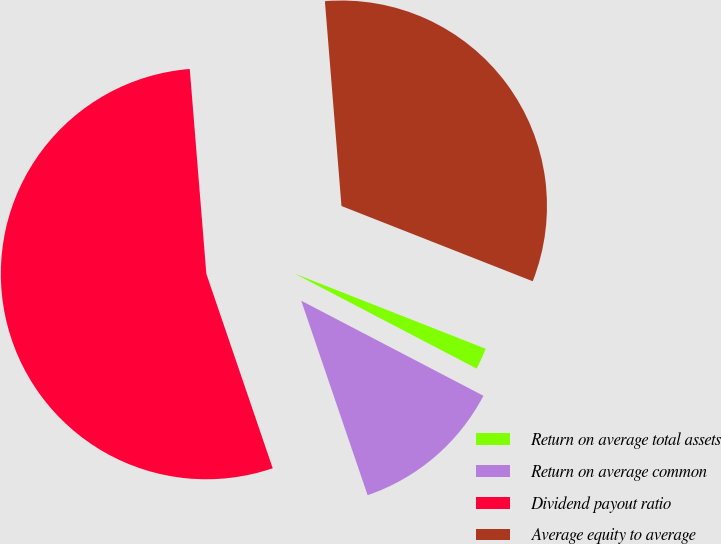Convert chart to OTSL. <chart><loc_0><loc_0><loc_500><loc_500><pie_chart><fcel>Return on average total assets<fcel>Return on average common<fcel>Dividend payout ratio<fcel>Average equity to average<nl><fcel>1.69%<fcel>12.11%<fcel>53.95%<fcel>32.25%<nl></chart> 